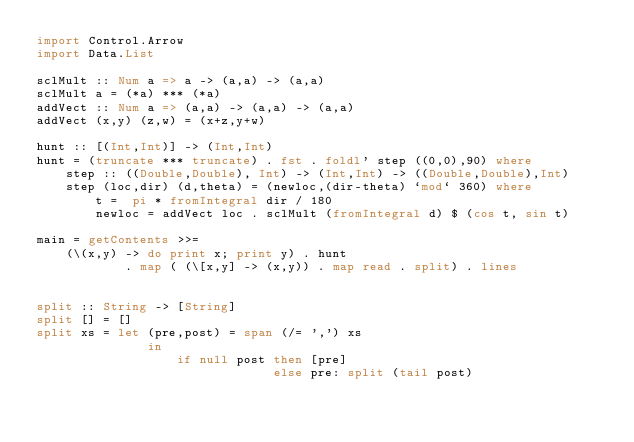<code> <loc_0><loc_0><loc_500><loc_500><_Haskell_>import Control.Arrow
import Data.List

sclMult :: Num a => a -> (a,a) -> (a,a)
sclMult a = (*a) *** (*a)
addVect :: Num a => (a,a) -> (a,a) -> (a,a)
addVect (x,y) (z,w) = (x+z,y+w)

hunt :: [(Int,Int)] -> (Int,Int)
hunt = (truncate *** truncate) . fst . foldl' step ((0,0),90) where
    step :: ((Double,Double), Int) -> (Int,Int) -> ((Double,Double),Int)
    step (loc,dir) (d,theta) = (newloc,(dir-theta) `mod` 360) where
        t =  pi * fromIntegral dir / 180
        newloc = addVect loc . sclMult (fromIntegral d) $ (cos t, sin t)

main = getContents >>=
    (\(x,y) -> do print x; print y) . hunt
            . map ( (\[x,y] -> (x,y)) . map read . split) . lines


split :: String -> [String]
split [] = []
split xs = let (pre,post) = span (/= ',') xs
               in
                   if null post then [pre]
                                else pre: split (tail post)</code> 